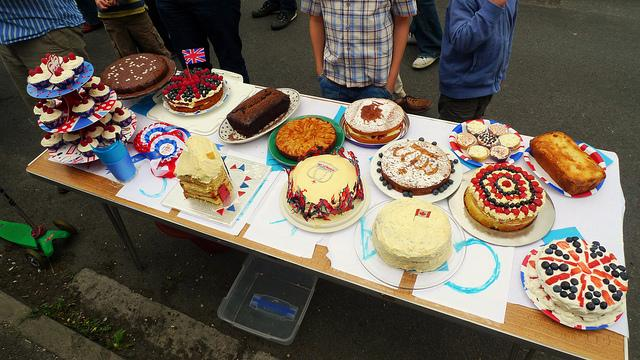The flag of what country is placed in the berry cake?

Choices:
A) united kingdom
B) france
C) sweden
D) germany united kingdom 